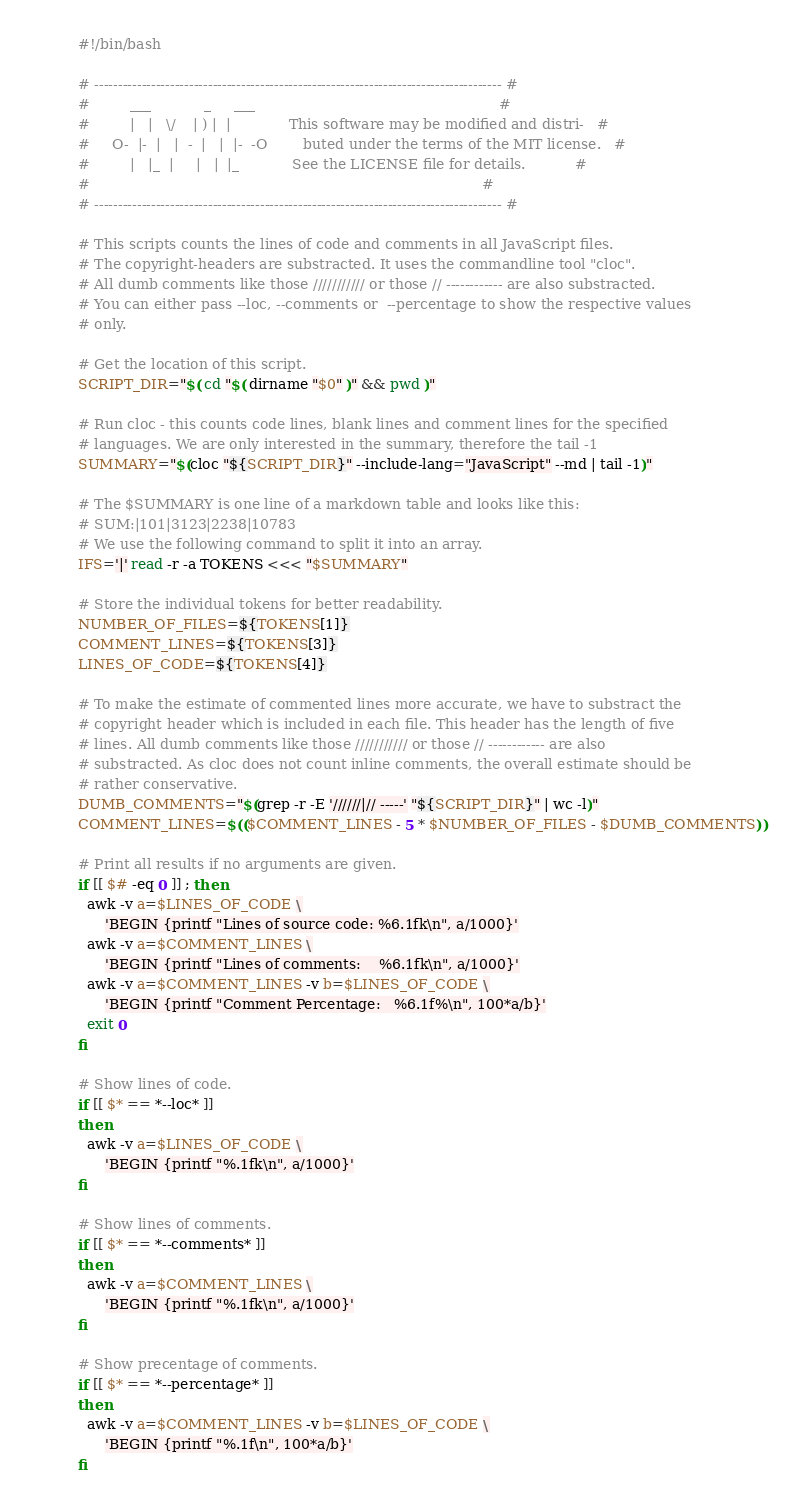<code> <loc_0><loc_0><loc_500><loc_500><_Bash_>#!/bin/bash

# -------------------------------------------------------------------------------------- #
#         ___            _     ___                                                       #
#         |   |   \/    | ) |  |             This software may be modified and distri-   #
#     O-  |-  |   |  -  |   |  |-  -O        buted under the terms of the MIT license.   #
#         |   |_  |     |   |  |_            See the LICENSE file for details.           #
#                                                                                        #
# -------------------------------------------------------------------------------------- #

# This scripts counts the lines of code and comments in all JavaScript files.
# The copyright-headers are substracted. It uses the commandline tool "cloc".
# All dumb comments like those /////////// or those // ------------ are also substracted.
# You can either pass --loc, --comments or  --percentage to show the respective values
# only.

# Get the location of this script.
SCRIPT_DIR="$( cd "$( dirname "$0" )" && pwd )"

# Run cloc - this counts code lines, blank lines and comment lines for the specified
# languages. We are only interested in the summary, therefore the tail -1
SUMMARY="$(cloc "${SCRIPT_DIR}" --include-lang="JavaScript" --md | tail -1)"

# The $SUMMARY is one line of a markdown table and looks like this:
# SUM:|101|3123|2238|10783
# We use the following command to split it into an array.
IFS='|' read -r -a TOKENS <<< "$SUMMARY"

# Store the individual tokens for better readability.
NUMBER_OF_FILES=${TOKENS[1]}
COMMENT_LINES=${TOKENS[3]}
LINES_OF_CODE=${TOKENS[4]}

# To make the estimate of commented lines more accurate, we have to substract the
# copyright header which is included in each file. This header has the length of five
# lines. All dumb comments like those /////////// or those // ------------ are also
# substracted. As cloc does not count inline comments, the overall estimate should be
# rather conservative.
DUMB_COMMENTS="$(grep -r -E '//////|// -----' "${SCRIPT_DIR}" | wc -l)"
COMMENT_LINES=$(($COMMENT_LINES - 5 * $NUMBER_OF_FILES - $DUMB_COMMENTS))

# Print all results if no arguments are given.
if [[ $# -eq 0 ]] ; then
  awk -v a=$LINES_OF_CODE \
      'BEGIN {printf "Lines of source code: %6.1fk\n", a/1000}'
  awk -v a=$COMMENT_LINES \
      'BEGIN {printf "Lines of comments:    %6.1fk\n", a/1000}'
  awk -v a=$COMMENT_LINES -v b=$LINES_OF_CODE \
      'BEGIN {printf "Comment Percentage:   %6.1f%\n", 100*a/b}'
  exit 0
fi

# Show lines of code.
if [[ $* == *--loc* ]]
then
  awk -v a=$LINES_OF_CODE \
      'BEGIN {printf "%.1fk\n", a/1000}'
fi

# Show lines of comments.
if [[ $* == *--comments* ]]
then
  awk -v a=$COMMENT_LINES \
      'BEGIN {printf "%.1fk\n", a/1000}'
fi

# Show precentage of comments.
if [[ $* == *--percentage* ]]
then
  awk -v a=$COMMENT_LINES -v b=$LINES_OF_CODE \
      'BEGIN {printf "%.1f\n", 100*a/b}'
fi</code> 